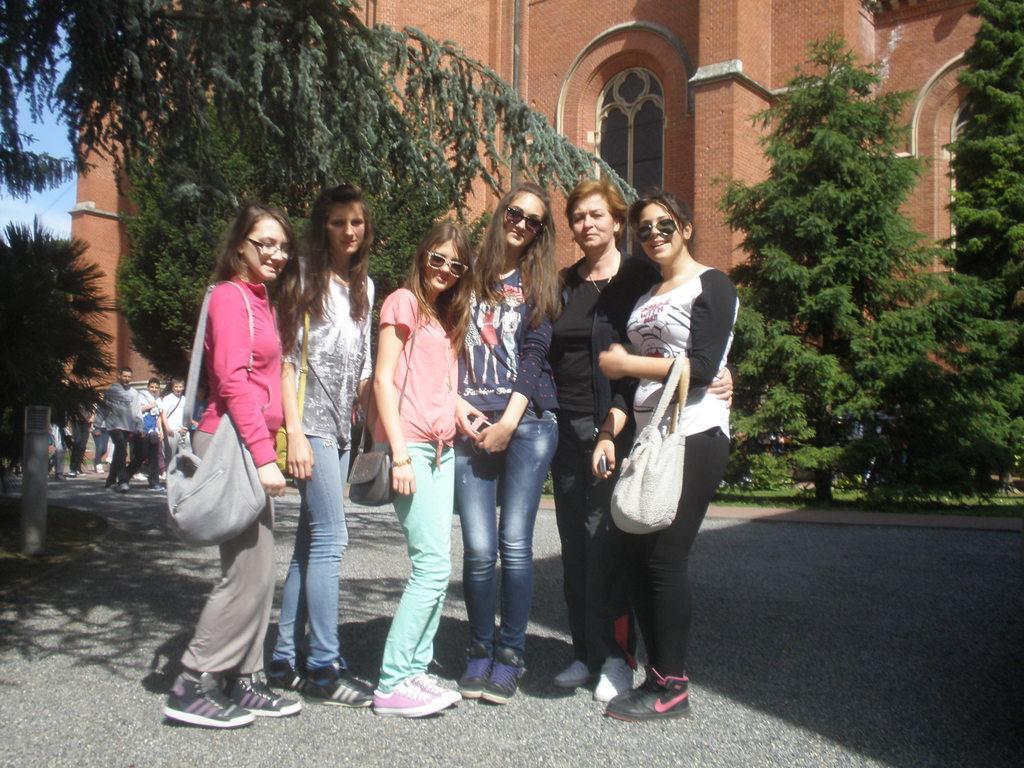How would you summarize this image in a sentence or two? In this picture we can see six women are standing in the front, four of them are carrying bags, there are some people walking on the left side, we can see trees in the middle, in the background there is a building and the sky. 